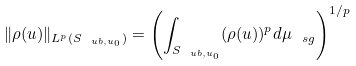<formula> <loc_0><loc_0><loc_500><loc_500>\| \rho ( u ) \| _ { L ^ { p } ( S _ { \ u b , u _ { 0 } } ) } = \left ( \int _ { S _ { \ u b , u _ { 0 } } } ( \rho ( u ) ) ^ { p } d \mu _ { \ s g } \right ) ^ { 1 / p }</formula> 